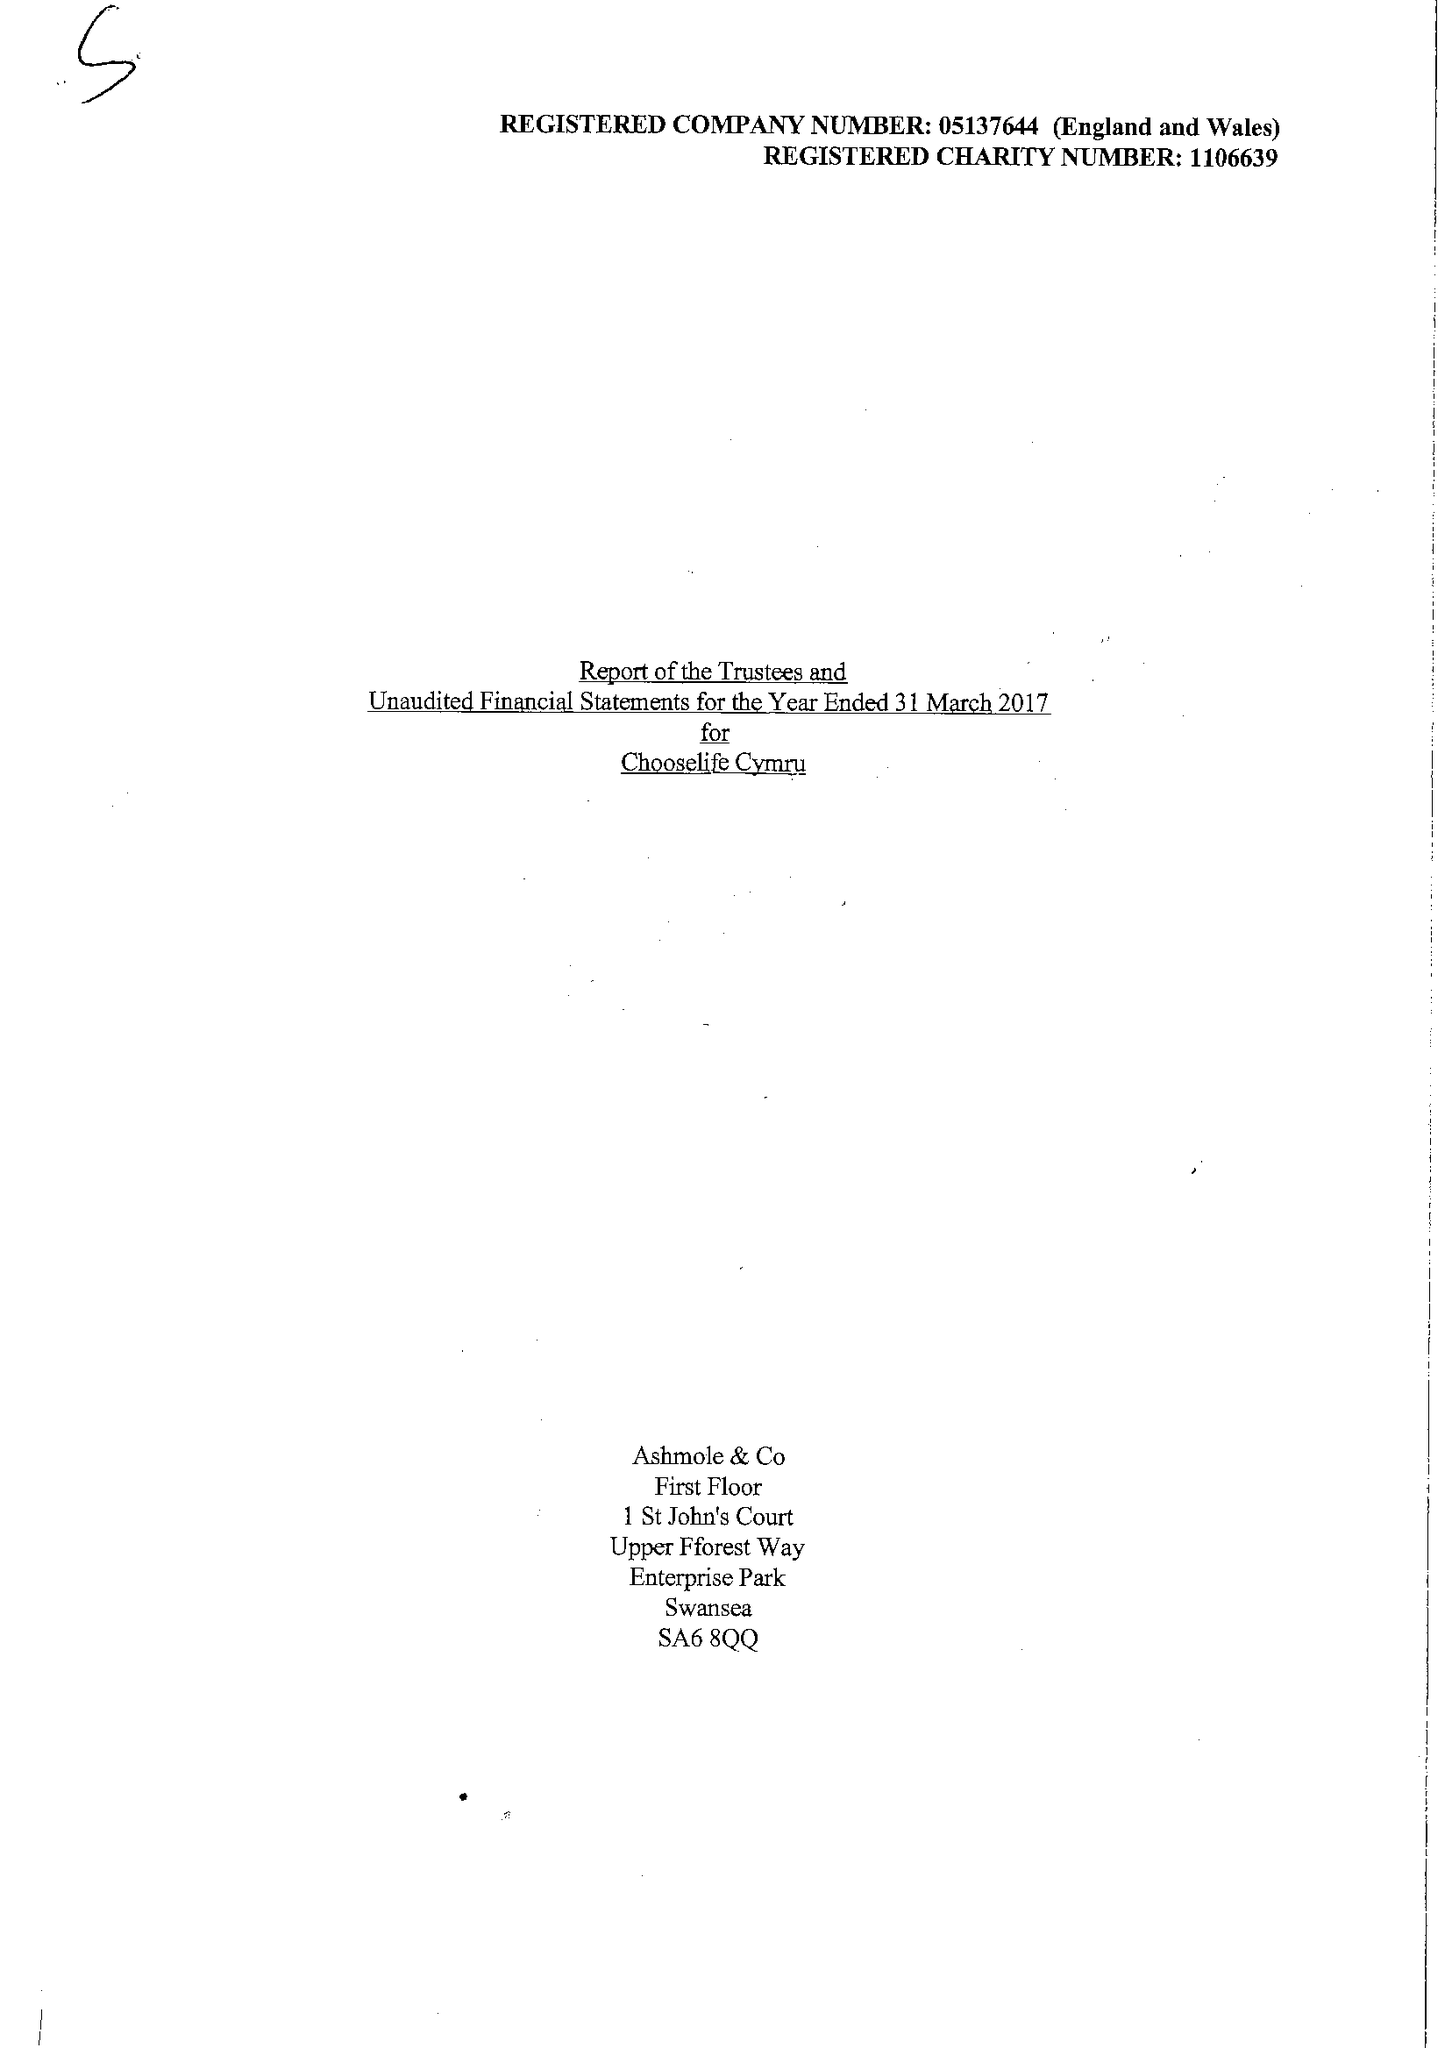What is the value for the charity_number?
Answer the question using a single word or phrase. 1106639 